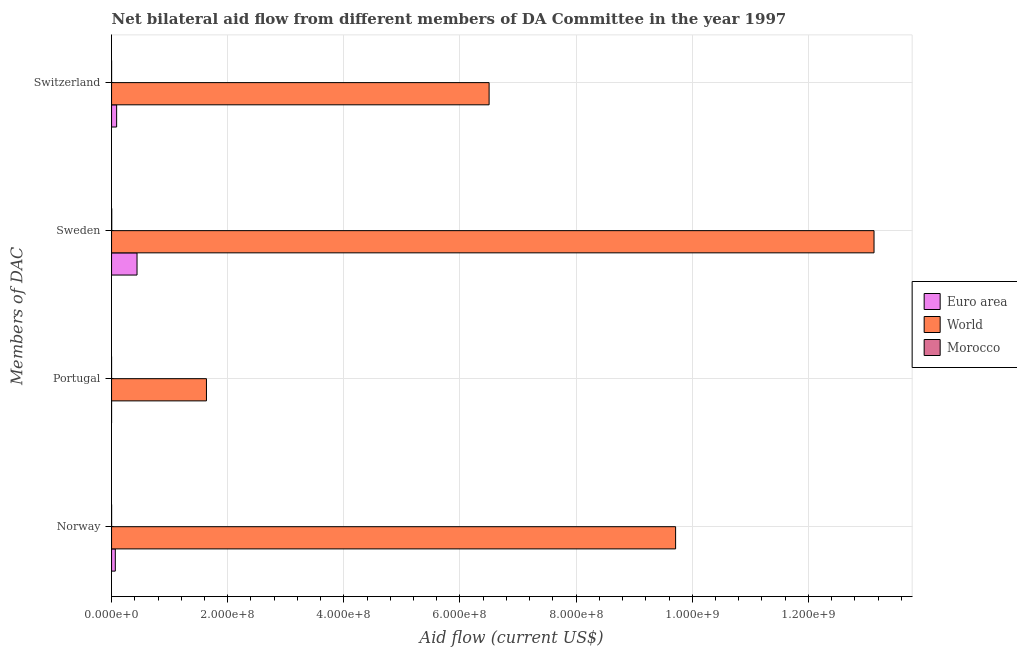How many groups of bars are there?
Keep it short and to the point. 4. Are the number of bars on each tick of the Y-axis equal?
Your response must be concise. Yes. How many bars are there on the 2nd tick from the top?
Your answer should be very brief. 3. What is the amount of aid given by norway in Euro area?
Offer a terse response. 6.46e+06. Across all countries, what is the maximum amount of aid given by norway?
Offer a very short reply. 9.71e+08. Across all countries, what is the minimum amount of aid given by switzerland?
Your response must be concise. 7.00e+04. In which country was the amount of aid given by switzerland minimum?
Ensure brevity in your answer.  Morocco. What is the total amount of aid given by switzerland in the graph?
Keep it short and to the point. 6.59e+08. What is the difference between the amount of aid given by sweden in Euro area and that in World?
Ensure brevity in your answer.  -1.27e+09. What is the difference between the amount of aid given by switzerland in Morocco and the amount of aid given by norway in Euro area?
Ensure brevity in your answer.  -6.39e+06. What is the average amount of aid given by switzerland per country?
Offer a terse response. 2.20e+08. What is the difference between the amount of aid given by portugal and amount of aid given by switzerland in World?
Your answer should be very brief. -4.87e+08. In how many countries, is the amount of aid given by portugal greater than 1320000000 US$?
Provide a short and direct response. 0. What is the ratio of the amount of aid given by sweden in World to that in Euro area?
Keep it short and to the point. 29.93. Is the amount of aid given by portugal in World less than that in Morocco?
Your response must be concise. No. Is the difference between the amount of aid given by sweden in Euro area and Morocco greater than the difference between the amount of aid given by switzerland in Euro area and Morocco?
Provide a short and direct response. Yes. What is the difference between the highest and the second highest amount of aid given by switzerland?
Ensure brevity in your answer.  6.41e+08. What is the difference between the highest and the lowest amount of aid given by portugal?
Your response must be concise. 1.63e+08. In how many countries, is the amount of aid given by norway greater than the average amount of aid given by norway taken over all countries?
Offer a terse response. 1. Is the sum of the amount of aid given by switzerland in World and Morocco greater than the maximum amount of aid given by sweden across all countries?
Offer a terse response. No. How many bars are there?
Give a very brief answer. 12. What is the difference between two consecutive major ticks on the X-axis?
Offer a very short reply. 2.00e+08. Does the graph contain any zero values?
Offer a very short reply. No. Does the graph contain grids?
Ensure brevity in your answer.  Yes. Where does the legend appear in the graph?
Give a very brief answer. Center right. How are the legend labels stacked?
Your answer should be compact. Vertical. What is the title of the graph?
Give a very brief answer. Net bilateral aid flow from different members of DA Committee in the year 1997. What is the label or title of the X-axis?
Your answer should be compact. Aid flow (current US$). What is the label or title of the Y-axis?
Your answer should be compact. Members of DAC. What is the Aid flow (current US$) of Euro area in Norway?
Offer a terse response. 6.46e+06. What is the Aid flow (current US$) of World in Norway?
Make the answer very short. 9.71e+08. What is the Aid flow (current US$) of Morocco in Norway?
Your answer should be very brief. 8.00e+04. What is the Aid flow (current US$) in World in Portugal?
Provide a short and direct response. 1.63e+08. What is the Aid flow (current US$) in Morocco in Portugal?
Make the answer very short. 10000. What is the Aid flow (current US$) in Euro area in Sweden?
Your response must be concise. 4.39e+07. What is the Aid flow (current US$) of World in Sweden?
Your answer should be compact. 1.31e+09. What is the Aid flow (current US$) in Morocco in Sweden?
Provide a short and direct response. 3.40e+05. What is the Aid flow (current US$) in Euro area in Switzerland?
Offer a very short reply. 8.76e+06. What is the Aid flow (current US$) of World in Switzerland?
Offer a very short reply. 6.50e+08. Across all Members of DAC, what is the maximum Aid flow (current US$) of Euro area?
Your response must be concise. 4.39e+07. Across all Members of DAC, what is the maximum Aid flow (current US$) in World?
Your response must be concise. 1.31e+09. Across all Members of DAC, what is the minimum Aid flow (current US$) of World?
Your response must be concise. 1.63e+08. What is the total Aid flow (current US$) in Euro area in the graph?
Offer a very short reply. 5.91e+07. What is the total Aid flow (current US$) of World in the graph?
Provide a succinct answer. 3.10e+09. What is the difference between the Aid flow (current US$) of Euro area in Norway and that in Portugal?
Keep it short and to the point. 6.45e+06. What is the difference between the Aid flow (current US$) of World in Norway and that in Portugal?
Your response must be concise. 8.08e+08. What is the difference between the Aid flow (current US$) in Morocco in Norway and that in Portugal?
Provide a succinct answer. 7.00e+04. What is the difference between the Aid flow (current US$) in Euro area in Norway and that in Sweden?
Your answer should be very brief. -3.74e+07. What is the difference between the Aid flow (current US$) in World in Norway and that in Sweden?
Your response must be concise. -3.42e+08. What is the difference between the Aid flow (current US$) in Morocco in Norway and that in Sweden?
Your answer should be very brief. -2.60e+05. What is the difference between the Aid flow (current US$) in Euro area in Norway and that in Switzerland?
Provide a short and direct response. -2.30e+06. What is the difference between the Aid flow (current US$) in World in Norway and that in Switzerland?
Ensure brevity in your answer.  3.21e+08. What is the difference between the Aid flow (current US$) in Euro area in Portugal and that in Sweden?
Your response must be concise. -4.39e+07. What is the difference between the Aid flow (current US$) in World in Portugal and that in Sweden?
Offer a terse response. -1.15e+09. What is the difference between the Aid flow (current US$) of Morocco in Portugal and that in Sweden?
Keep it short and to the point. -3.30e+05. What is the difference between the Aid flow (current US$) of Euro area in Portugal and that in Switzerland?
Your answer should be compact. -8.75e+06. What is the difference between the Aid flow (current US$) in World in Portugal and that in Switzerland?
Offer a terse response. -4.87e+08. What is the difference between the Aid flow (current US$) of Euro area in Sweden and that in Switzerland?
Offer a terse response. 3.51e+07. What is the difference between the Aid flow (current US$) of World in Sweden and that in Switzerland?
Give a very brief answer. 6.63e+08. What is the difference between the Aid flow (current US$) in Euro area in Norway and the Aid flow (current US$) in World in Portugal?
Offer a terse response. -1.57e+08. What is the difference between the Aid flow (current US$) of Euro area in Norway and the Aid flow (current US$) of Morocco in Portugal?
Make the answer very short. 6.45e+06. What is the difference between the Aid flow (current US$) in World in Norway and the Aid flow (current US$) in Morocco in Portugal?
Your response must be concise. 9.71e+08. What is the difference between the Aid flow (current US$) of Euro area in Norway and the Aid flow (current US$) of World in Sweden?
Your answer should be very brief. -1.31e+09. What is the difference between the Aid flow (current US$) in Euro area in Norway and the Aid flow (current US$) in Morocco in Sweden?
Ensure brevity in your answer.  6.12e+06. What is the difference between the Aid flow (current US$) of World in Norway and the Aid flow (current US$) of Morocco in Sweden?
Make the answer very short. 9.71e+08. What is the difference between the Aid flow (current US$) in Euro area in Norway and the Aid flow (current US$) in World in Switzerland?
Your response must be concise. -6.44e+08. What is the difference between the Aid flow (current US$) in Euro area in Norway and the Aid flow (current US$) in Morocco in Switzerland?
Make the answer very short. 6.39e+06. What is the difference between the Aid flow (current US$) in World in Norway and the Aid flow (current US$) in Morocco in Switzerland?
Ensure brevity in your answer.  9.71e+08. What is the difference between the Aid flow (current US$) in Euro area in Portugal and the Aid flow (current US$) in World in Sweden?
Your response must be concise. -1.31e+09. What is the difference between the Aid flow (current US$) of Euro area in Portugal and the Aid flow (current US$) of Morocco in Sweden?
Offer a terse response. -3.30e+05. What is the difference between the Aid flow (current US$) in World in Portugal and the Aid flow (current US$) in Morocco in Sweden?
Your answer should be compact. 1.63e+08. What is the difference between the Aid flow (current US$) in Euro area in Portugal and the Aid flow (current US$) in World in Switzerland?
Your response must be concise. -6.50e+08. What is the difference between the Aid flow (current US$) in World in Portugal and the Aid flow (current US$) in Morocco in Switzerland?
Give a very brief answer. 1.63e+08. What is the difference between the Aid flow (current US$) of Euro area in Sweden and the Aid flow (current US$) of World in Switzerland?
Provide a succinct answer. -6.06e+08. What is the difference between the Aid flow (current US$) in Euro area in Sweden and the Aid flow (current US$) in Morocco in Switzerland?
Keep it short and to the point. 4.38e+07. What is the difference between the Aid flow (current US$) in World in Sweden and the Aid flow (current US$) in Morocco in Switzerland?
Provide a short and direct response. 1.31e+09. What is the average Aid flow (current US$) of Euro area per Members of DAC?
Make the answer very short. 1.48e+07. What is the average Aid flow (current US$) in World per Members of DAC?
Your answer should be compact. 7.74e+08. What is the average Aid flow (current US$) in Morocco per Members of DAC?
Your answer should be very brief. 1.25e+05. What is the difference between the Aid flow (current US$) in Euro area and Aid flow (current US$) in World in Norway?
Offer a terse response. -9.65e+08. What is the difference between the Aid flow (current US$) of Euro area and Aid flow (current US$) of Morocco in Norway?
Provide a succinct answer. 6.38e+06. What is the difference between the Aid flow (current US$) in World and Aid flow (current US$) in Morocco in Norway?
Your response must be concise. 9.71e+08. What is the difference between the Aid flow (current US$) of Euro area and Aid flow (current US$) of World in Portugal?
Your answer should be compact. -1.63e+08. What is the difference between the Aid flow (current US$) in World and Aid flow (current US$) in Morocco in Portugal?
Offer a terse response. 1.63e+08. What is the difference between the Aid flow (current US$) of Euro area and Aid flow (current US$) of World in Sweden?
Offer a terse response. -1.27e+09. What is the difference between the Aid flow (current US$) in Euro area and Aid flow (current US$) in Morocco in Sweden?
Ensure brevity in your answer.  4.35e+07. What is the difference between the Aid flow (current US$) in World and Aid flow (current US$) in Morocco in Sweden?
Provide a succinct answer. 1.31e+09. What is the difference between the Aid flow (current US$) of Euro area and Aid flow (current US$) of World in Switzerland?
Offer a very short reply. -6.41e+08. What is the difference between the Aid flow (current US$) in Euro area and Aid flow (current US$) in Morocco in Switzerland?
Give a very brief answer. 8.69e+06. What is the difference between the Aid flow (current US$) in World and Aid flow (current US$) in Morocco in Switzerland?
Give a very brief answer. 6.50e+08. What is the ratio of the Aid flow (current US$) of Euro area in Norway to that in Portugal?
Give a very brief answer. 646. What is the ratio of the Aid flow (current US$) in World in Norway to that in Portugal?
Give a very brief answer. 5.94. What is the ratio of the Aid flow (current US$) in Morocco in Norway to that in Portugal?
Make the answer very short. 8. What is the ratio of the Aid flow (current US$) of Euro area in Norway to that in Sweden?
Keep it short and to the point. 0.15. What is the ratio of the Aid flow (current US$) in World in Norway to that in Sweden?
Keep it short and to the point. 0.74. What is the ratio of the Aid flow (current US$) of Morocco in Norway to that in Sweden?
Provide a succinct answer. 0.24. What is the ratio of the Aid flow (current US$) in Euro area in Norway to that in Switzerland?
Offer a terse response. 0.74. What is the ratio of the Aid flow (current US$) of World in Norway to that in Switzerland?
Offer a very short reply. 1.49. What is the ratio of the Aid flow (current US$) of Morocco in Norway to that in Switzerland?
Your response must be concise. 1.14. What is the ratio of the Aid flow (current US$) in Euro area in Portugal to that in Sweden?
Your response must be concise. 0. What is the ratio of the Aid flow (current US$) in World in Portugal to that in Sweden?
Provide a succinct answer. 0.12. What is the ratio of the Aid flow (current US$) in Morocco in Portugal to that in Sweden?
Your answer should be compact. 0.03. What is the ratio of the Aid flow (current US$) of Euro area in Portugal to that in Switzerland?
Provide a short and direct response. 0. What is the ratio of the Aid flow (current US$) of World in Portugal to that in Switzerland?
Your response must be concise. 0.25. What is the ratio of the Aid flow (current US$) of Morocco in Portugal to that in Switzerland?
Keep it short and to the point. 0.14. What is the ratio of the Aid flow (current US$) of Euro area in Sweden to that in Switzerland?
Your answer should be very brief. 5.01. What is the ratio of the Aid flow (current US$) of World in Sweden to that in Switzerland?
Ensure brevity in your answer.  2.02. What is the ratio of the Aid flow (current US$) in Morocco in Sweden to that in Switzerland?
Keep it short and to the point. 4.86. What is the difference between the highest and the second highest Aid flow (current US$) of Euro area?
Give a very brief answer. 3.51e+07. What is the difference between the highest and the second highest Aid flow (current US$) in World?
Provide a short and direct response. 3.42e+08. What is the difference between the highest and the lowest Aid flow (current US$) of Euro area?
Offer a terse response. 4.39e+07. What is the difference between the highest and the lowest Aid flow (current US$) of World?
Provide a succinct answer. 1.15e+09. What is the difference between the highest and the lowest Aid flow (current US$) in Morocco?
Offer a terse response. 3.30e+05. 